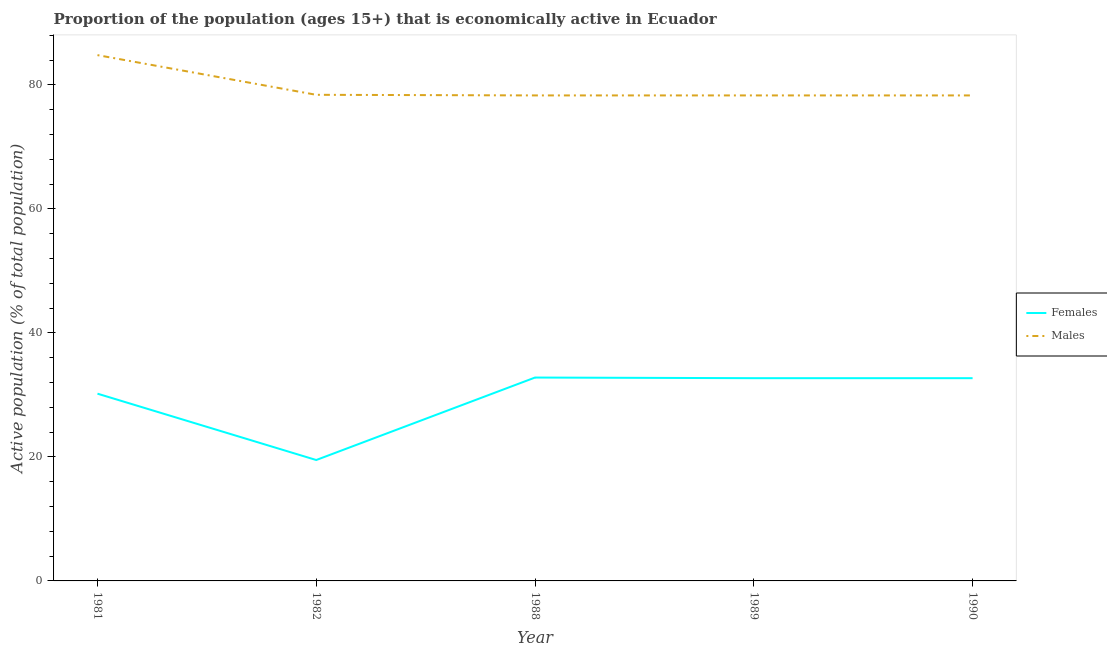How many different coloured lines are there?
Keep it short and to the point. 2. What is the percentage of economically active male population in 1981?
Provide a short and direct response. 84.8. Across all years, what is the maximum percentage of economically active male population?
Your answer should be very brief. 84.8. Across all years, what is the minimum percentage of economically active female population?
Keep it short and to the point. 19.5. In which year was the percentage of economically active female population maximum?
Offer a terse response. 1988. In which year was the percentage of economically active male population minimum?
Keep it short and to the point. 1988. What is the total percentage of economically active female population in the graph?
Provide a short and direct response. 147.9. What is the difference between the percentage of economically active male population in 1981 and that in 1982?
Keep it short and to the point. 6.4. What is the difference between the percentage of economically active female population in 1990 and the percentage of economically active male population in 1982?
Offer a terse response. -45.7. What is the average percentage of economically active female population per year?
Offer a very short reply. 29.58. In the year 1990, what is the difference between the percentage of economically active female population and percentage of economically active male population?
Offer a terse response. -45.6. In how many years, is the percentage of economically active female population greater than 56 %?
Offer a terse response. 0. What is the ratio of the percentage of economically active female population in 1982 to that in 1988?
Keep it short and to the point. 0.59. Is the percentage of economically active female population in 1988 less than that in 1990?
Offer a very short reply. No. What is the difference between the highest and the second highest percentage of economically active female population?
Ensure brevity in your answer.  0.1. What is the difference between the highest and the lowest percentage of economically active female population?
Keep it short and to the point. 13.3. In how many years, is the percentage of economically active male population greater than the average percentage of economically active male population taken over all years?
Your answer should be compact. 1. Is the percentage of economically active female population strictly greater than the percentage of economically active male population over the years?
Your answer should be compact. No. How many years are there in the graph?
Provide a short and direct response. 5. What is the difference between two consecutive major ticks on the Y-axis?
Ensure brevity in your answer.  20. Are the values on the major ticks of Y-axis written in scientific E-notation?
Ensure brevity in your answer.  No. Does the graph contain grids?
Offer a very short reply. No. What is the title of the graph?
Ensure brevity in your answer.  Proportion of the population (ages 15+) that is economically active in Ecuador. Does "Import" appear as one of the legend labels in the graph?
Your answer should be very brief. No. What is the label or title of the X-axis?
Ensure brevity in your answer.  Year. What is the label or title of the Y-axis?
Keep it short and to the point. Active population (% of total population). What is the Active population (% of total population) of Females in 1981?
Your answer should be compact. 30.2. What is the Active population (% of total population) of Males in 1981?
Your answer should be compact. 84.8. What is the Active population (% of total population) in Males in 1982?
Your response must be concise. 78.4. What is the Active population (% of total population) in Females in 1988?
Offer a very short reply. 32.8. What is the Active population (% of total population) of Males in 1988?
Ensure brevity in your answer.  78.3. What is the Active population (% of total population) in Females in 1989?
Provide a succinct answer. 32.7. What is the Active population (% of total population) of Males in 1989?
Your response must be concise. 78.3. What is the Active population (% of total population) of Females in 1990?
Your answer should be compact. 32.7. What is the Active population (% of total population) of Males in 1990?
Offer a terse response. 78.3. Across all years, what is the maximum Active population (% of total population) of Females?
Your response must be concise. 32.8. Across all years, what is the maximum Active population (% of total population) of Males?
Offer a terse response. 84.8. Across all years, what is the minimum Active population (% of total population) of Females?
Your answer should be compact. 19.5. Across all years, what is the minimum Active population (% of total population) of Males?
Offer a very short reply. 78.3. What is the total Active population (% of total population) in Females in the graph?
Make the answer very short. 147.9. What is the total Active population (% of total population) of Males in the graph?
Your response must be concise. 398.1. What is the difference between the Active population (% of total population) in Males in 1981 and that in 1989?
Your answer should be very brief. 6.5. What is the difference between the Active population (% of total population) of Males in 1982 and that in 1988?
Offer a very short reply. 0.1. What is the difference between the Active population (% of total population) in Females in 1982 and that in 1989?
Offer a very short reply. -13.2. What is the difference between the Active population (% of total population) of Males in 1982 and that in 1989?
Make the answer very short. 0.1. What is the difference between the Active population (% of total population) in Females in 1988 and that in 1990?
Your answer should be compact. 0.1. What is the difference between the Active population (% of total population) in Females in 1989 and that in 1990?
Your response must be concise. 0. What is the difference between the Active population (% of total population) in Females in 1981 and the Active population (% of total population) in Males in 1982?
Give a very brief answer. -48.2. What is the difference between the Active population (% of total population) in Females in 1981 and the Active population (% of total population) in Males in 1988?
Offer a very short reply. -48.1. What is the difference between the Active population (% of total population) of Females in 1981 and the Active population (% of total population) of Males in 1989?
Your answer should be very brief. -48.1. What is the difference between the Active population (% of total population) in Females in 1981 and the Active population (% of total population) in Males in 1990?
Keep it short and to the point. -48.1. What is the difference between the Active population (% of total population) in Females in 1982 and the Active population (% of total population) in Males in 1988?
Your answer should be very brief. -58.8. What is the difference between the Active population (% of total population) of Females in 1982 and the Active population (% of total population) of Males in 1989?
Give a very brief answer. -58.8. What is the difference between the Active population (% of total population) in Females in 1982 and the Active population (% of total population) in Males in 1990?
Provide a short and direct response. -58.8. What is the difference between the Active population (% of total population) of Females in 1988 and the Active population (% of total population) of Males in 1989?
Make the answer very short. -45.5. What is the difference between the Active population (% of total population) in Females in 1988 and the Active population (% of total population) in Males in 1990?
Offer a terse response. -45.5. What is the difference between the Active population (% of total population) in Females in 1989 and the Active population (% of total population) in Males in 1990?
Offer a very short reply. -45.6. What is the average Active population (% of total population) in Females per year?
Offer a very short reply. 29.58. What is the average Active population (% of total population) in Males per year?
Your response must be concise. 79.62. In the year 1981, what is the difference between the Active population (% of total population) in Females and Active population (% of total population) in Males?
Give a very brief answer. -54.6. In the year 1982, what is the difference between the Active population (% of total population) of Females and Active population (% of total population) of Males?
Keep it short and to the point. -58.9. In the year 1988, what is the difference between the Active population (% of total population) of Females and Active population (% of total population) of Males?
Give a very brief answer. -45.5. In the year 1989, what is the difference between the Active population (% of total population) of Females and Active population (% of total population) of Males?
Provide a short and direct response. -45.6. In the year 1990, what is the difference between the Active population (% of total population) of Females and Active population (% of total population) of Males?
Provide a short and direct response. -45.6. What is the ratio of the Active population (% of total population) of Females in 1981 to that in 1982?
Your response must be concise. 1.55. What is the ratio of the Active population (% of total population) of Males in 1981 to that in 1982?
Provide a short and direct response. 1.08. What is the ratio of the Active population (% of total population) of Females in 1981 to that in 1988?
Your answer should be compact. 0.92. What is the ratio of the Active population (% of total population) of Males in 1981 to that in 1988?
Your answer should be very brief. 1.08. What is the ratio of the Active population (% of total population) in Females in 1981 to that in 1989?
Your answer should be very brief. 0.92. What is the ratio of the Active population (% of total population) in Males in 1981 to that in 1989?
Your response must be concise. 1.08. What is the ratio of the Active population (% of total population) of Females in 1981 to that in 1990?
Offer a terse response. 0.92. What is the ratio of the Active population (% of total population) of Males in 1981 to that in 1990?
Your answer should be very brief. 1.08. What is the ratio of the Active population (% of total population) in Females in 1982 to that in 1988?
Your answer should be compact. 0.59. What is the ratio of the Active population (% of total population) in Females in 1982 to that in 1989?
Your answer should be compact. 0.6. What is the ratio of the Active population (% of total population) of Males in 1982 to that in 1989?
Your response must be concise. 1. What is the ratio of the Active population (% of total population) in Females in 1982 to that in 1990?
Your answer should be compact. 0.6. What is the ratio of the Active population (% of total population) in Males in 1988 to that in 1989?
Provide a succinct answer. 1. What is the ratio of the Active population (% of total population) of Females in 1988 to that in 1990?
Provide a succinct answer. 1. What is the ratio of the Active population (% of total population) in Males in 1988 to that in 1990?
Make the answer very short. 1. What is the ratio of the Active population (% of total population) in Females in 1989 to that in 1990?
Offer a very short reply. 1. What is the difference between the highest and the lowest Active population (% of total population) of Females?
Make the answer very short. 13.3. 